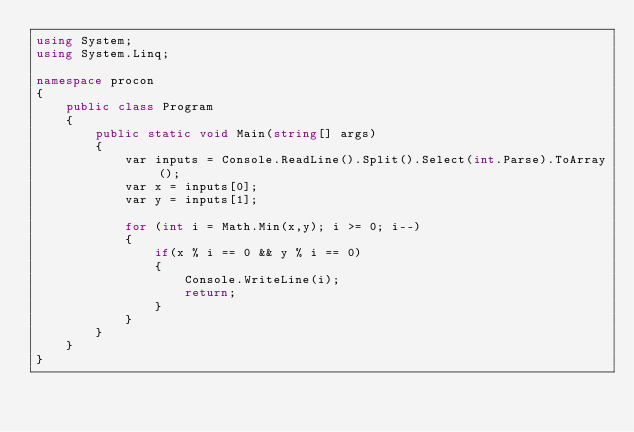<code> <loc_0><loc_0><loc_500><loc_500><_C#_>using System;
using System.Linq;

namespace procon
{
    public class Program
    {
        public static void Main(string[] args)
        {
            var inputs = Console.ReadLine().Split().Select(int.Parse).ToArray();
            var x = inputs[0];
            var y = inputs[1];
            
            for (int i = Math.Min(x,y); i >= 0; i--)
            {
                if(x % i == 0 && y % i == 0)
                {
                    Console.WriteLine(i);
                    return;
                }
            }
        }
    }
}</code> 